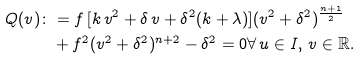Convert formula to latex. <formula><loc_0><loc_0><loc_500><loc_500>Q ( v ) \colon & = f \, [ k \, v ^ { 2 } + \delta \, v + \delta ^ { 2 } ( k + \lambda ) ] ( v ^ { 2 } + \delta ^ { 2 } ) ^ { \frac { n + 1 } { 2 } } \\ & + f ^ { 2 } ( v ^ { 2 } + \delta ^ { 2 } ) ^ { n + 2 } - \delta ^ { 2 } = 0 \forall \, u \in I , \, v \in \mathbb { R } .</formula> 